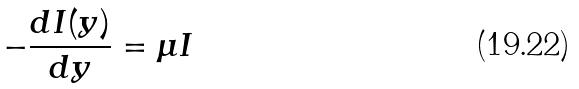<formula> <loc_0><loc_0><loc_500><loc_500>- \frac { d I ( y ) } { d y } = \mu I</formula> 